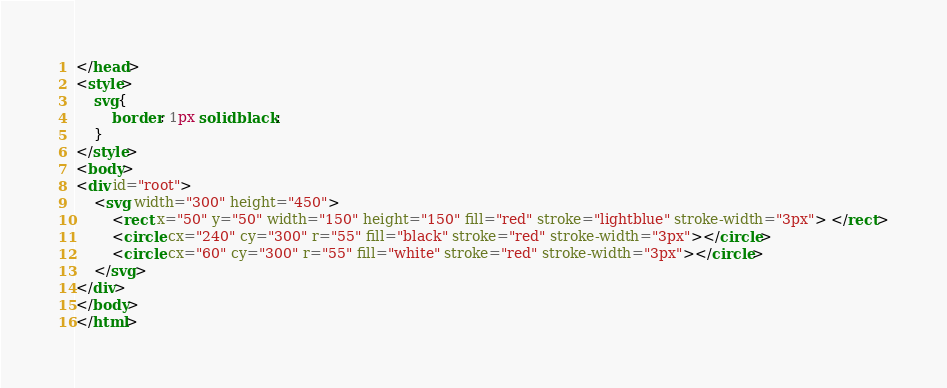<code> <loc_0><loc_0><loc_500><loc_500><_HTML_></head>
<style>
    svg{
        border: 1px solid black;
    }
</style>
<body>
<div id="root">
    <svg width="300" height="450">
        <rect x="50" y="50" width="150" height="150" fill="red" stroke="lightblue" stroke-width="3px"> </rect>
        <circle cx="240" cy="300" r="55" fill="black" stroke="red" stroke-width="3px"></circle>
        <circle cx="60" cy="300" r="55" fill="white" stroke="red" stroke-width="3px"></circle>
    </svg>
</div>
</body>
</html></code> 